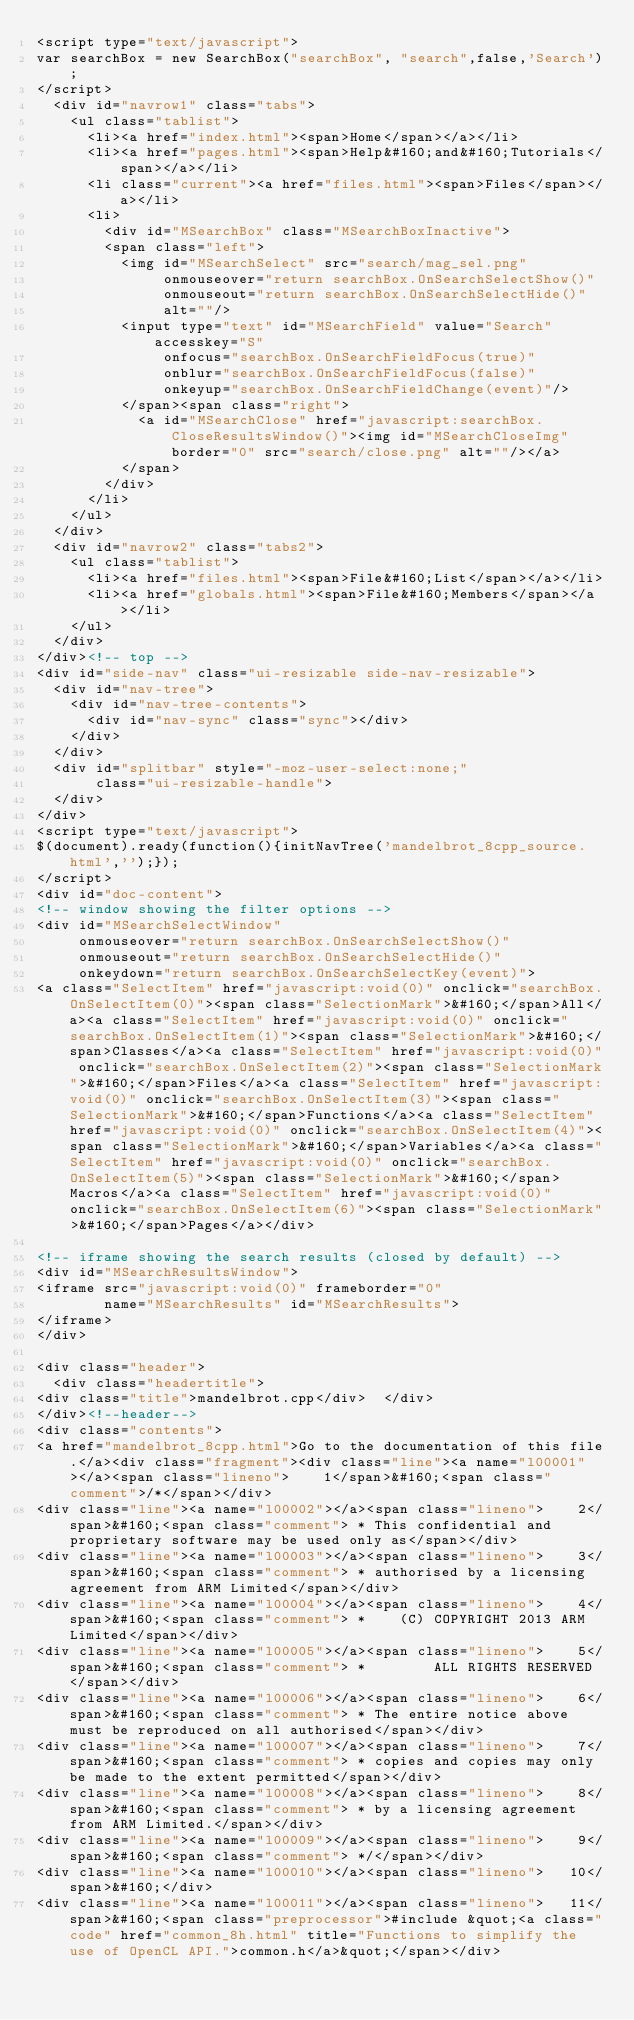Convert code to text. <code><loc_0><loc_0><loc_500><loc_500><_HTML_><script type="text/javascript">
var searchBox = new SearchBox("searchBox", "search",false,'Search');
</script>
  <div id="navrow1" class="tabs">
    <ul class="tablist">
      <li><a href="index.html"><span>Home</span></a></li>
      <li><a href="pages.html"><span>Help&#160;and&#160;Tutorials</span></a></li>
      <li class="current"><a href="files.html"><span>Files</span></a></li>
      <li>
        <div id="MSearchBox" class="MSearchBoxInactive">
        <span class="left">
          <img id="MSearchSelect" src="search/mag_sel.png"
               onmouseover="return searchBox.OnSearchSelectShow()"
               onmouseout="return searchBox.OnSearchSelectHide()"
               alt=""/>
          <input type="text" id="MSearchField" value="Search" accesskey="S"
               onfocus="searchBox.OnSearchFieldFocus(true)" 
               onblur="searchBox.OnSearchFieldFocus(false)" 
               onkeyup="searchBox.OnSearchFieldChange(event)"/>
          </span><span class="right">
            <a id="MSearchClose" href="javascript:searchBox.CloseResultsWindow()"><img id="MSearchCloseImg" border="0" src="search/close.png" alt=""/></a>
          </span>
        </div>
      </li>
    </ul>
  </div>
  <div id="navrow2" class="tabs2">
    <ul class="tablist">
      <li><a href="files.html"><span>File&#160;List</span></a></li>
      <li><a href="globals.html"><span>File&#160;Members</span></a></li>
    </ul>
  </div>
</div><!-- top -->
<div id="side-nav" class="ui-resizable side-nav-resizable">
  <div id="nav-tree">
    <div id="nav-tree-contents">
      <div id="nav-sync" class="sync"></div>
    </div>
  </div>
  <div id="splitbar" style="-moz-user-select:none;" 
       class="ui-resizable-handle">
  </div>
</div>
<script type="text/javascript">
$(document).ready(function(){initNavTree('mandelbrot_8cpp_source.html','');});
</script>
<div id="doc-content">
<!-- window showing the filter options -->
<div id="MSearchSelectWindow"
     onmouseover="return searchBox.OnSearchSelectShow()"
     onmouseout="return searchBox.OnSearchSelectHide()"
     onkeydown="return searchBox.OnSearchSelectKey(event)">
<a class="SelectItem" href="javascript:void(0)" onclick="searchBox.OnSelectItem(0)"><span class="SelectionMark">&#160;</span>All</a><a class="SelectItem" href="javascript:void(0)" onclick="searchBox.OnSelectItem(1)"><span class="SelectionMark">&#160;</span>Classes</a><a class="SelectItem" href="javascript:void(0)" onclick="searchBox.OnSelectItem(2)"><span class="SelectionMark">&#160;</span>Files</a><a class="SelectItem" href="javascript:void(0)" onclick="searchBox.OnSelectItem(3)"><span class="SelectionMark">&#160;</span>Functions</a><a class="SelectItem" href="javascript:void(0)" onclick="searchBox.OnSelectItem(4)"><span class="SelectionMark">&#160;</span>Variables</a><a class="SelectItem" href="javascript:void(0)" onclick="searchBox.OnSelectItem(5)"><span class="SelectionMark">&#160;</span>Macros</a><a class="SelectItem" href="javascript:void(0)" onclick="searchBox.OnSelectItem(6)"><span class="SelectionMark">&#160;</span>Pages</a></div>

<!-- iframe showing the search results (closed by default) -->
<div id="MSearchResultsWindow">
<iframe src="javascript:void(0)" frameborder="0" 
        name="MSearchResults" id="MSearchResults">
</iframe>
</div>

<div class="header">
  <div class="headertitle">
<div class="title">mandelbrot.cpp</div>  </div>
</div><!--header-->
<div class="contents">
<a href="mandelbrot_8cpp.html">Go to the documentation of this file.</a><div class="fragment"><div class="line"><a name="l00001"></a><span class="lineno">    1</span>&#160;<span class="comment">/*</span></div>
<div class="line"><a name="l00002"></a><span class="lineno">    2</span>&#160;<span class="comment"> * This confidential and proprietary software may be used only as</span></div>
<div class="line"><a name="l00003"></a><span class="lineno">    3</span>&#160;<span class="comment"> * authorised by a licensing agreement from ARM Limited</span></div>
<div class="line"><a name="l00004"></a><span class="lineno">    4</span>&#160;<span class="comment"> *    (C) COPYRIGHT 2013 ARM Limited</span></div>
<div class="line"><a name="l00005"></a><span class="lineno">    5</span>&#160;<span class="comment"> *        ALL RIGHTS RESERVED</span></div>
<div class="line"><a name="l00006"></a><span class="lineno">    6</span>&#160;<span class="comment"> * The entire notice above must be reproduced on all authorised</span></div>
<div class="line"><a name="l00007"></a><span class="lineno">    7</span>&#160;<span class="comment"> * copies and copies may only be made to the extent permitted</span></div>
<div class="line"><a name="l00008"></a><span class="lineno">    8</span>&#160;<span class="comment"> * by a licensing agreement from ARM Limited.</span></div>
<div class="line"><a name="l00009"></a><span class="lineno">    9</span>&#160;<span class="comment"> */</span></div>
<div class="line"><a name="l00010"></a><span class="lineno">   10</span>&#160;</div>
<div class="line"><a name="l00011"></a><span class="lineno">   11</span>&#160;<span class="preprocessor">#include &quot;<a class="code" href="common_8h.html" title="Functions to simplify the use of OpenCL API.">common.h</a>&quot;</span></div></code> 